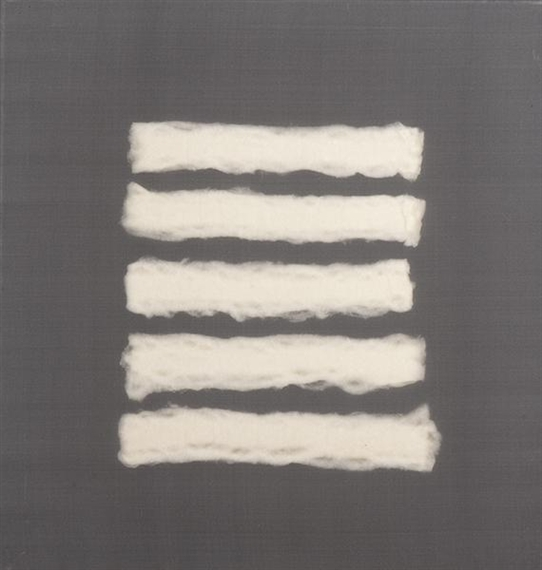Based on this image, what is a realistic scenario or context in which this artwork is displayed? This artwork could be realistically displayed in a modern, minimalist art gallery, where the clean and uncluttered space allows viewers to fully appreciate its simplicity and nuanced textures. The gallery setting would provide a serene environment, encouraging contemplation and personal interpretation. It might also be part of a private collection in a contemporary home, displayed in a living area with neutral tones and minimalist décor, where it adds a touch of sophistication and thoughtfulness to the space. Describe another realistic scenario where this could be found. Another realistic scenario is this artwork being featured in a corporate office's lobby or conference room. Here, its calming and balancing visual appeal would create an environment conducive to focus and creativity. The artwork could serve as a conversation starter, offering a point of interest that breaks the monotony of a typical office setting while subtly enhancing the space's aesthetic with its modern and abstract qualities. 